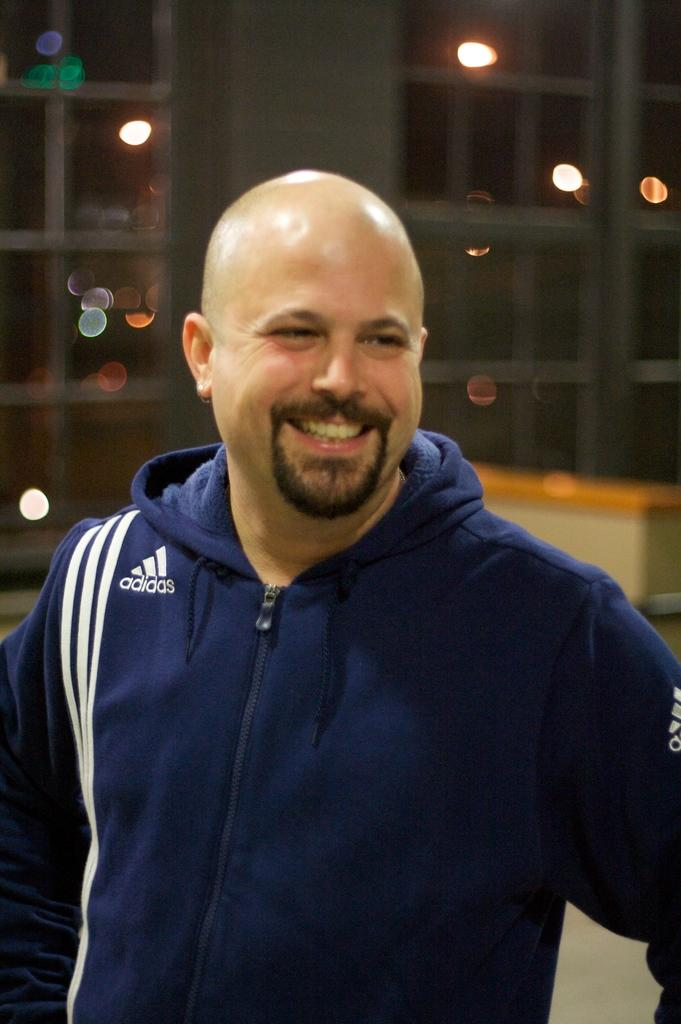What is the main subject of the image? There is a person standing in the image. What is the person's facial expression? The person is smiling. Can you describe the background of the image? The background of the image is blurry. What type of pump can be seen in the background of the image? There is no pump present in the background of the image. 